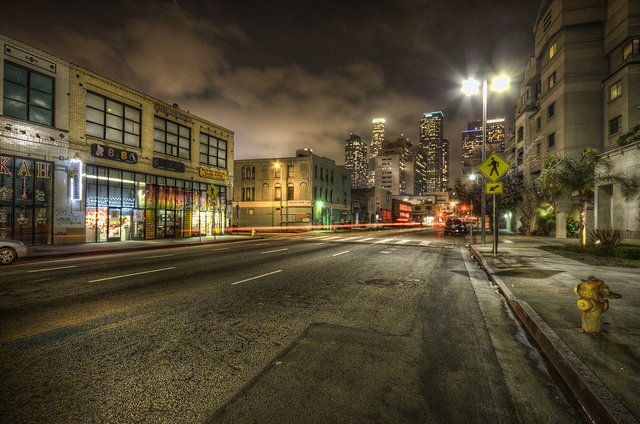Identify the text displayed in this image. KAH B 